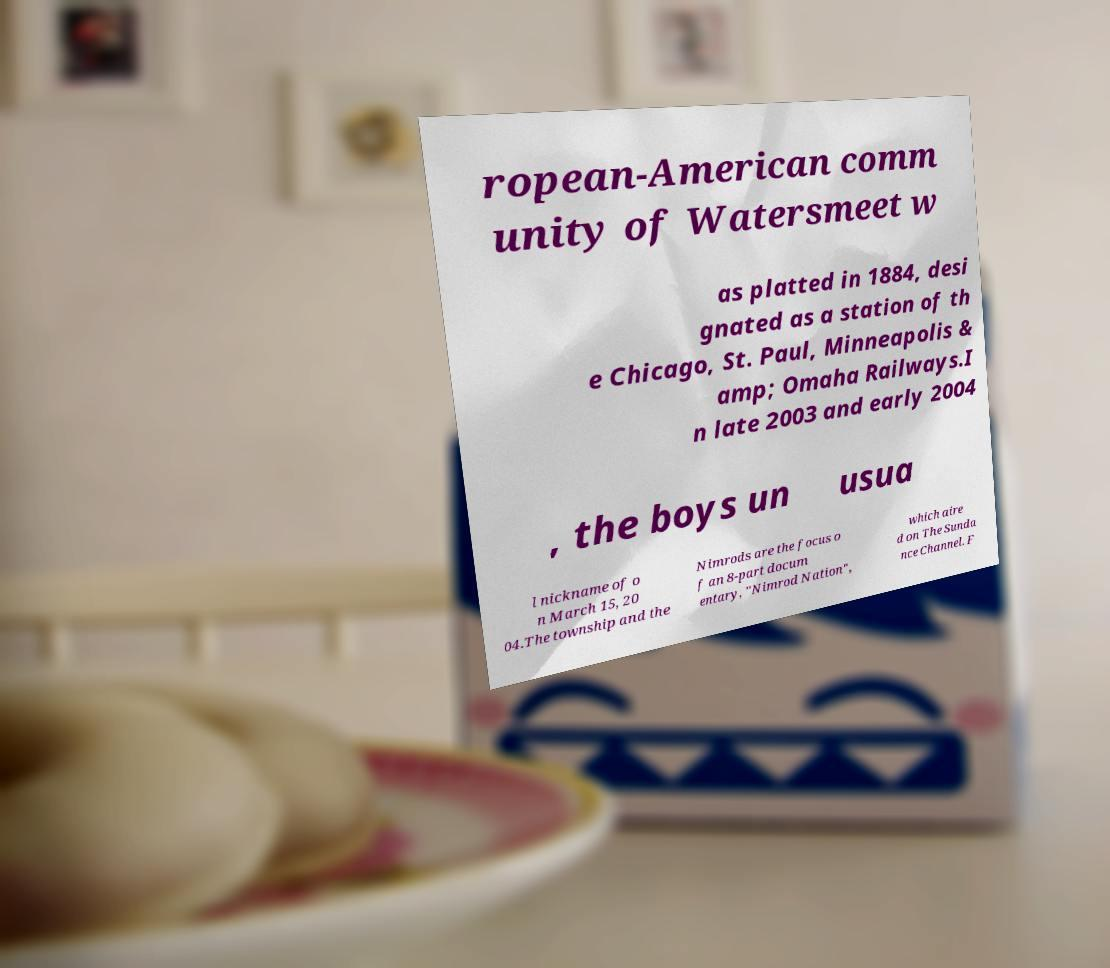There's text embedded in this image that I need extracted. Can you transcribe it verbatim? ropean-American comm unity of Watersmeet w as platted in 1884, desi gnated as a station of th e Chicago, St. Paul, Minneapolis & amp; Omaha Railways.I n late 2003 and early 2004 , the boys un usua l nickname of o n March 15, 20 04.The township and the Nimrods are the focus o f an 8-part docum entary, "Nimrod Nation", which aire d on The Sunda nce Channel. F 